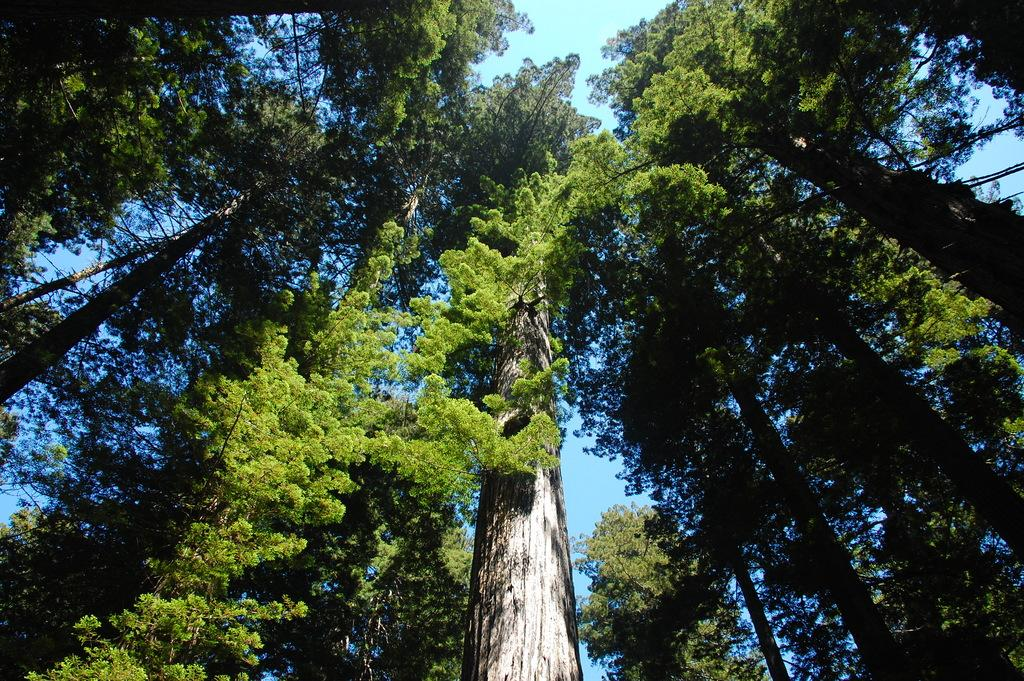What can be seen in the background of the image? The sky is visible in the image. What type of vegetation is present in the image? There are trees in the image. Where are the sky and trees located in the image? The sky and trees are in the center of the image. How much toothpaste is on the trees in the image? There is no toothpaste present on the trees in the image. What type of spiders can be seen crawling on the sky in the image? There are no spiders visible in the image, and the sky is not a surface where spiders would typically be found. 